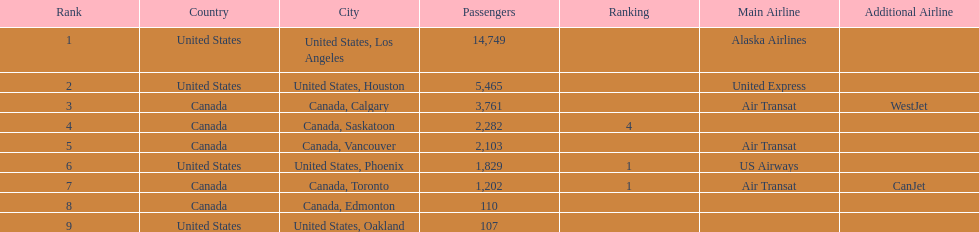How many more passengers flew to los angeles than to saskatoon from manzanillo airport in 2013? 12,467. 